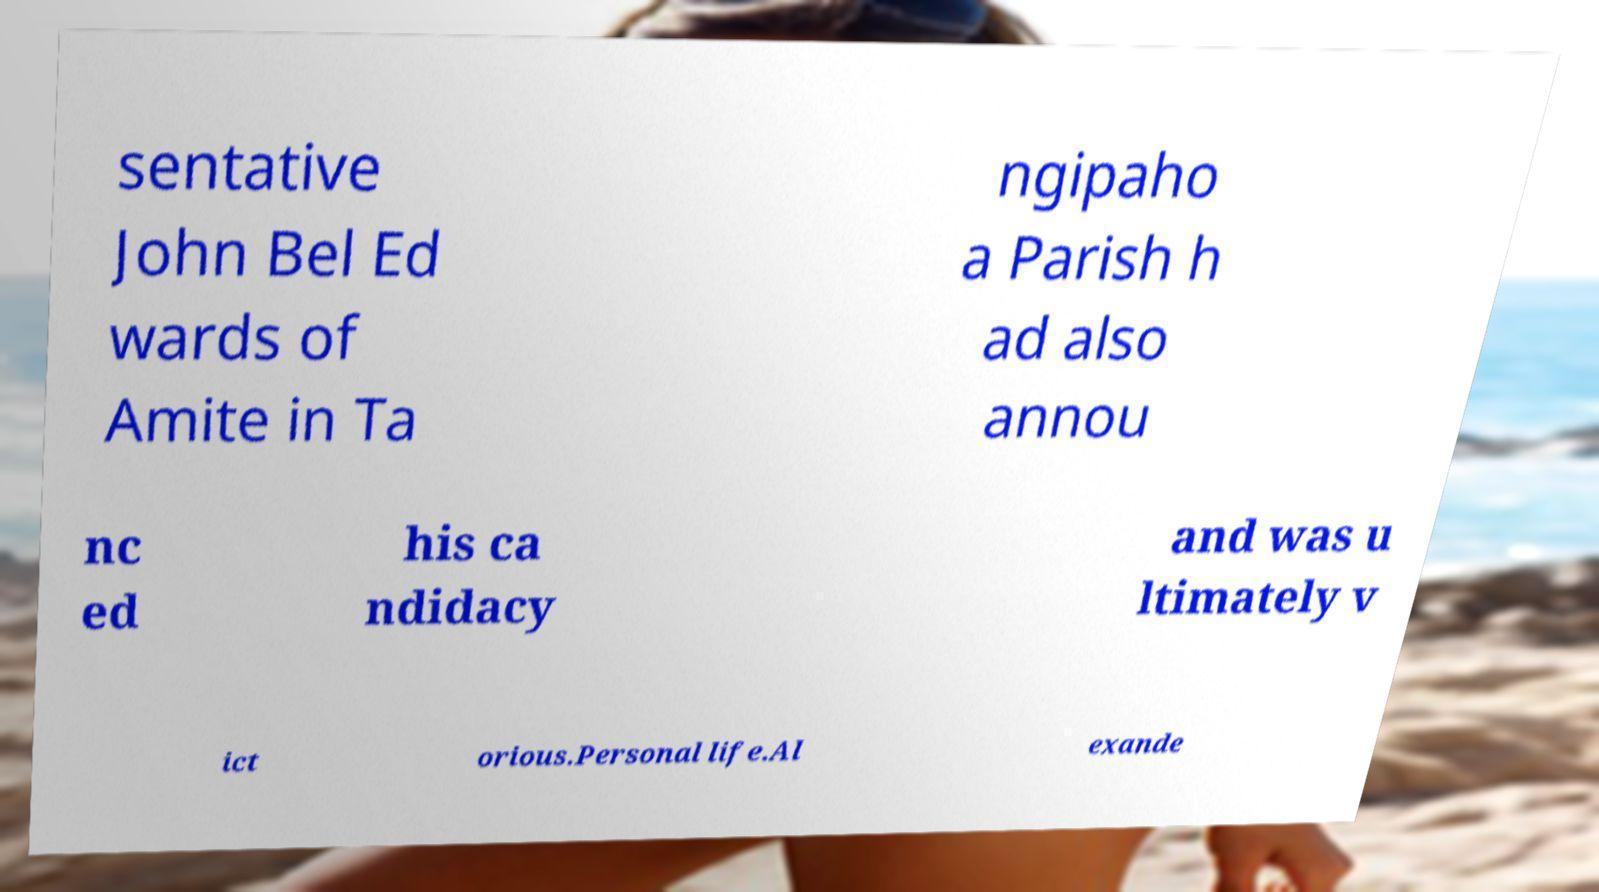What messages or text are displayed in this image? I need them in a readable, typed format. sentative John Bel Ed wards of Amite in Ta ngipaho a Parish h ad also annou nc ed his ca ndidacy and was u ltimately v ict orious.Personal life.Al exande 